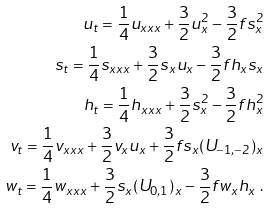<formula> <loc_0><loc_0><loc_500><loc_500>u _ { t } = \frac { 1 } { 4 } u _ { x x x } + \frac { 3 } { 2 } u _ { x } ^ { 2 } - \frac { 3 } { 2 } f s _ { x } ^ { 2 } \\ s _ { t } = \frac { 1 } { 4 } s _ { x x x } + \frac { 3 } { 2 } s _ { x } u _ { x } - \frac { 3 } { 2 } f h _ { x } s _ { x } \\ h _ { t } = \frac { 1 } { 4 } h _ { x x x } + \frac { 3 } { 2 } s _ { x } ^ { 2 } - \frac { 3 } { 2 } f h _ { x } ^ { 2 } \\ v _ { t } = \frac { 1 } { 4 } v _ { x x x } + \frac { 3 } { 2 } v _ { x } u _ { x } + \frac { 3 } { 2 } f s _ { x } ( U _ { - 1 , - 2 } ) _ { x } \\ w _ { t } = \frac { 1 } { 4 } w _ { x x x } + \frac { 3 } { 2 } s _ { x } ( U _ { 0 , 1 } ) _ { x } - \frac { 3 } { 2 } f w _ { x } h _ { x } \ .</formula> 